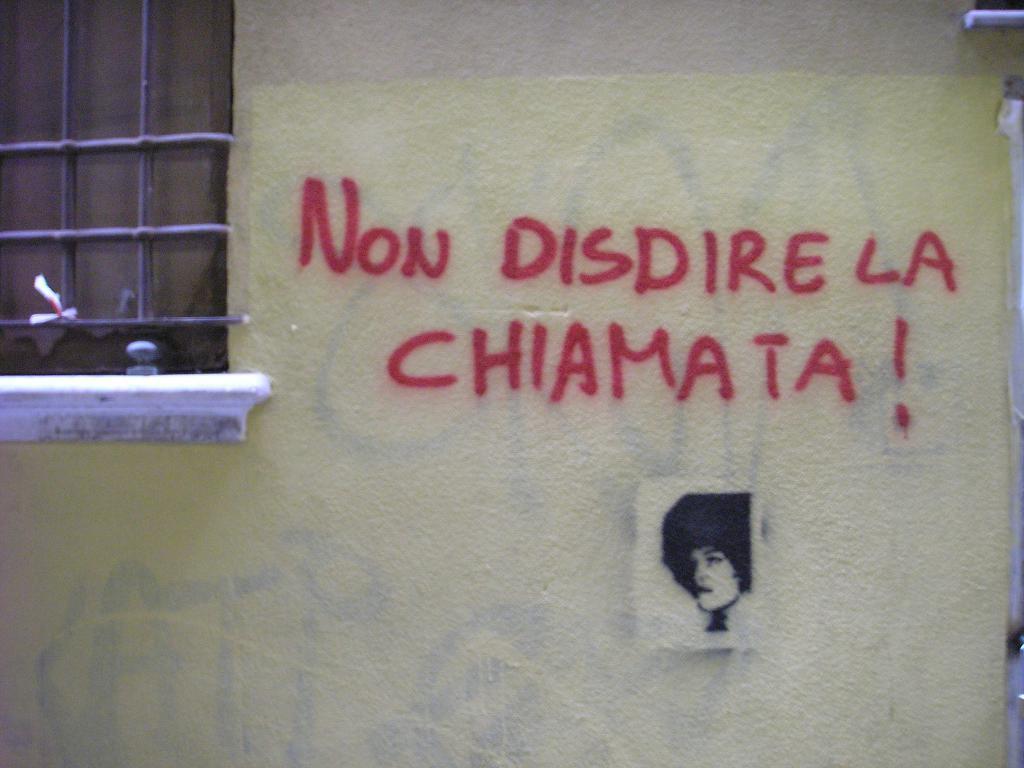How would you summarize this image in a sentence or two? In the image there is a wall and there is some text on the wall and there is a window on the left side and below the text there is a picture of a person. 